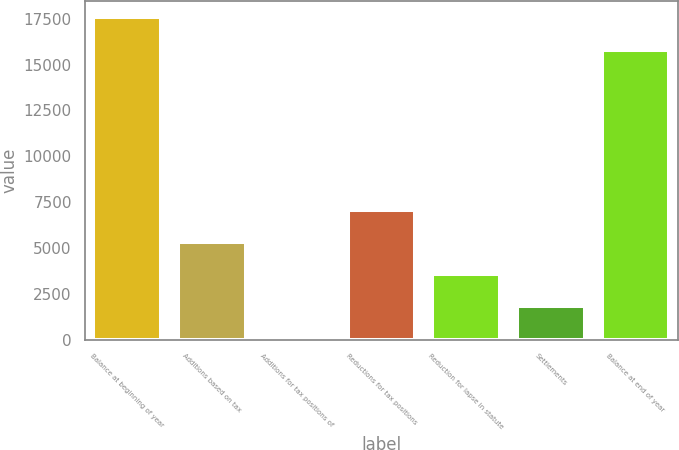Convert chart. <chart><loc_0><loc_0><loc_500><loc_500><bar_chart><fcel>Balance at beginning of year<fcel>Additions based on tax<fcel>Additions for tax positions of<fcel>Reductions for tax positions<fcel>Reduction for lapse in statute<fcel>Settlements<fcel>Balance at end of year<nl><fcel>17581<fcel>5317<fcel>61<fcel>7069<fcel>3565<fcel>1813<fcel>15815<nl></chart> 